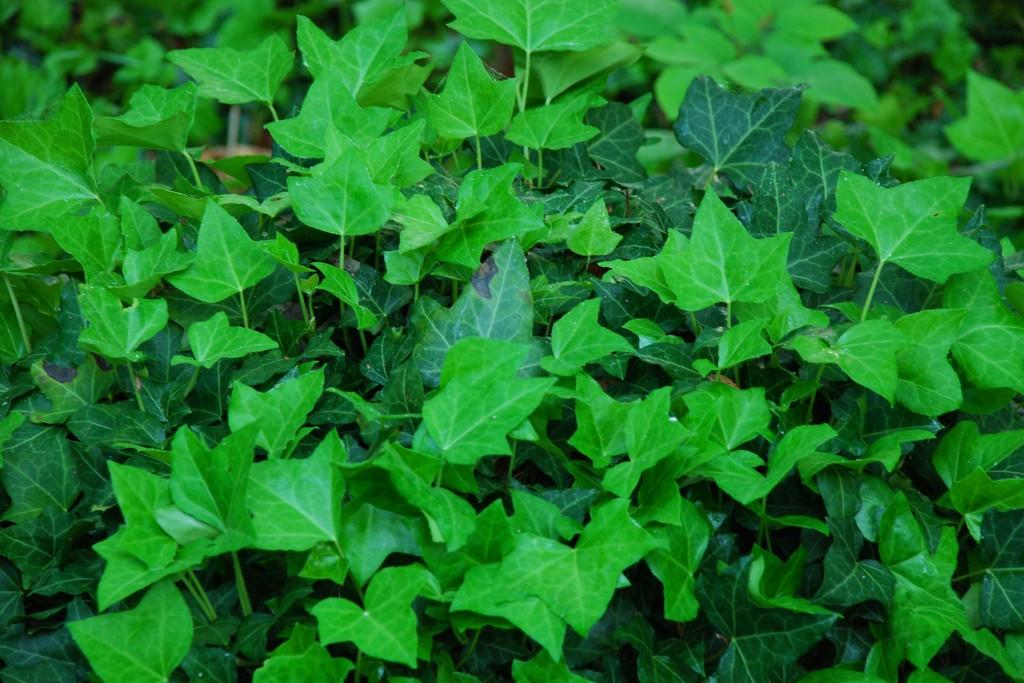What is the main subject in the center of the image? There are leaves in the center of the image. What type of shoes can be seen on the bear in the image? There is no bear or shoes present in the image; it only features leaves. 